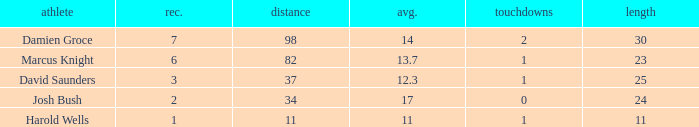How many TDs are there were the long is smaller than 23? 1.0. 